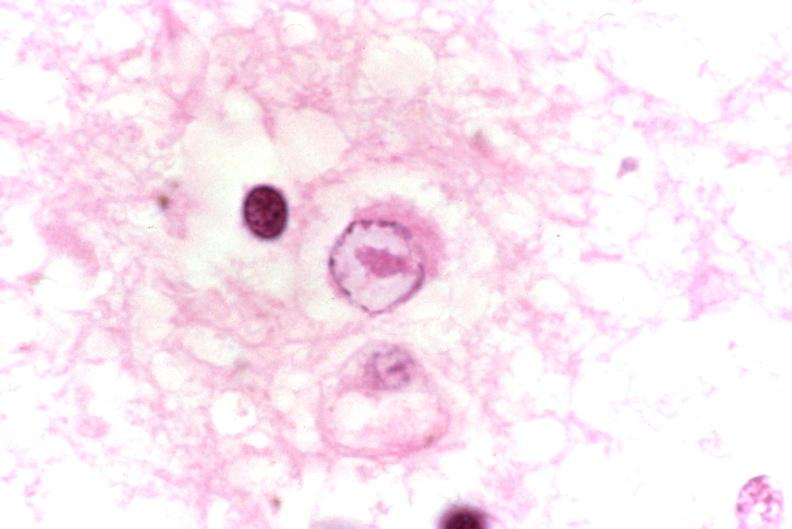what does this image show?
Answer the question using a single word or phrase. Brain 